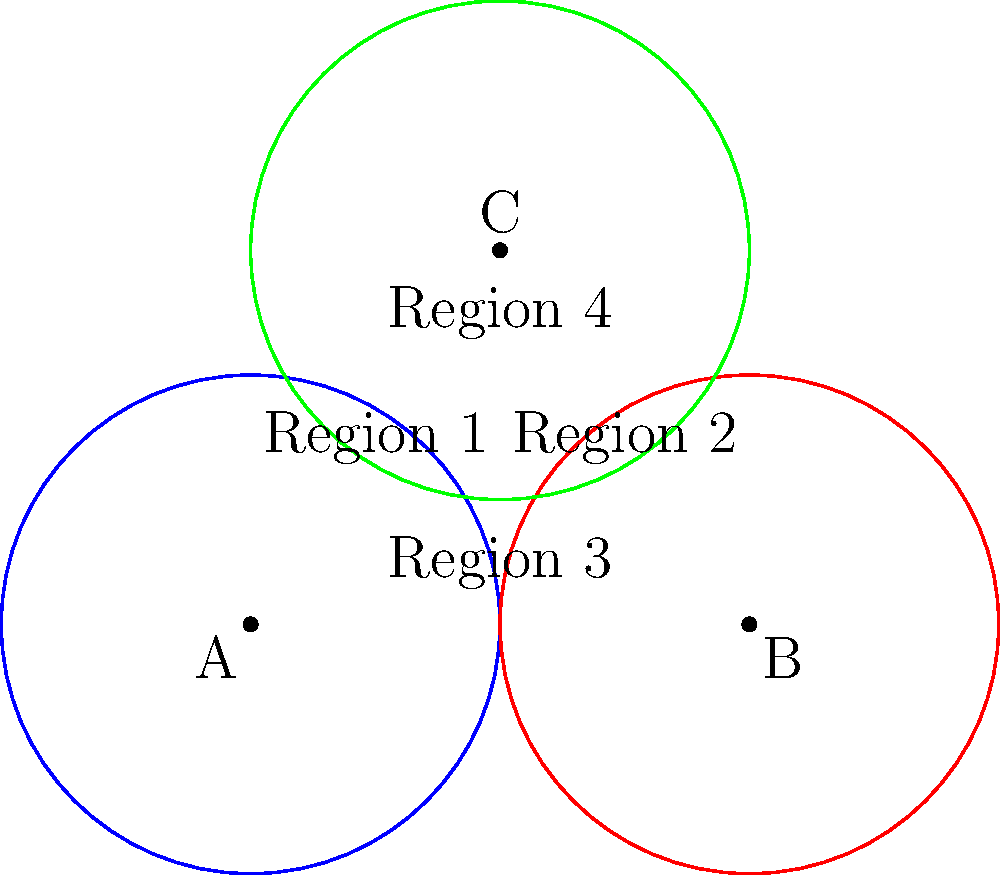In a remote area, your healthcare organization plans to establish three vaccination clinics represented by points A, B, and C on the map. Each clinic has a circular coverage area with a radius of 2 units. Calculate the total area covered by at least one clinic, given that the centers of the circles form a triangle with sides of length 4, 4, and $2\sqrt{3}$ units. Let's approach this step-by-step:

1) First, we need to calculate the area of a single circle:
   $$A_{circle} = \pi r^2 = \pi (2)^2 = 4\pi$$

2) The total area covered would be the sum of the areas of the three circles, minus the areas of overlap.

3) To find the areas of overlap, we need to calculate the areas of the lens-shaped regions formed by the intersections of the circles.

4) For two circles intersecting, the area of the lens is given by:
   $$A_{lens} = 2r^2 \arccos(\frac{d}{2r}) - d\sqrt{r^2 - (\frac{d}{2})^2}$$
   where $d$ is the distance between the centers and $r$ is the radius.

5) We have three lenses:
   - Between A and B: $d = 4$
   - Between B and C: $d = 4$
   - Between A and C: $d = 2\sqrt{3}$

6) Calculating the area of each lens:
   - For $d = 4$: 
     $$A_{lens1} = A_{lens2} = 2(2^2) \arccos(\frac{4}{2(2)}) - 4\sqrt{2^2 - 2^2} = 8 \arccos(1) - 0 = 0$$
   - For $d = 2\sqrt{3}$:
     $$A_{lens3} = 2(2^2) \arccos(\frac{2\sqrt{3}}{2(2)}) - 2\sqrt{3}\sqrt{2^2 - (\sqrt{3})^2}$$
     $$= 8 \arccos(\frac{\sqrt{3}}{2}) - 2\sqrt{3}$$

7) The area where all three circles overlap (Region 4 in the diagram) needs to be added back once, as it's been subtracted twice.
   This area can be found by subtracting the areas of the three sectors formed in circle C from the area of circle C:
   $$A_{triple} = \pi r^2 - 3(\frac{1}{3}\pi r^2) = 0$$

8) Therefore, the total area covered is:
   $$A_{total} = 3(4\pi) - A_{lens3} + A_{triple}$$
   $$= 12\pi - (8 \arccos(\frac{\sqrt{3}}{2}) - 2\sqrt{3})$$
   $$= 12\pi - 8 \arccos(\frac{\sqrt{3}}{2}) + 2\sqrt{3}$$
Answer: $12\pi - 8 \arccos(\frac{\sqrt{3}}{2}) + 2\sqrt{3}$ square units 